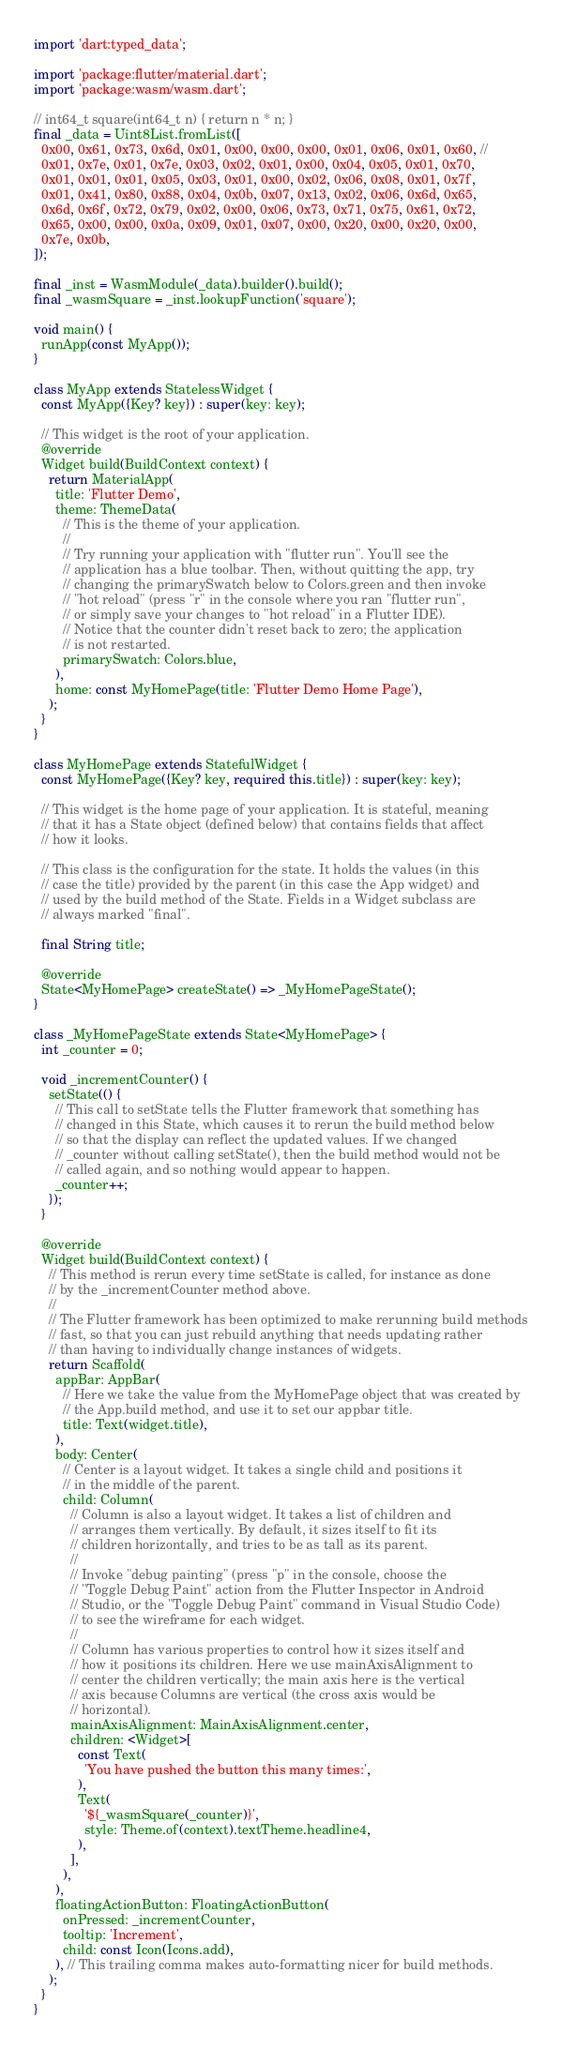<code> <loc_0><loc_0><loc_500><loc_500><_Dart_>import 'dart:typed_data';

import 'package:flutter/material.dart';
import 'package:wasm/wasm.dart';

// int64_t square(int64_t n) { return n * n; }
final _data = Uint8List.fromList([
  0x00, 0x61, 0x73, 0x6d, 0x01, 0x00, 0x00, 0x00, 0x01, 0x06, 0x01, 0x60, //
  0x01, 0x7e, 0x01, 0x7e, 0x03, 0x02, 0x01, 0x00, 0x04, 0x05, 0x01, 0x70,
  0x01, 0x01, 0x01, 0x05, 0x03, 0x01, 0x00, 0x02, 0x06, 0x08, 0x01, 0x7f,
  0x01, 0x41, 0x80, 0x88, 0x04, 0x0b, 0x07, 0x13, 0x02, 0x06, 0x6d, 0x65,
  0x6d, 0x6f, 0x72, 0x79, 0x02, 0x00, 0x06, 0x73, 0x71, 0x75, 0x61, 0x72,
  0x65, 0x00, 0x00, 0x0a, 0x09, 0x01, 0x07, 0x00, 0x20, 0x00, 0x20, 0x00,
  0x7e, 0x0b,
]);

final _inst = WasmModule(_data).builder().build();
final _wasmSquare = _inst.lookupFunction('square');

void main() {
  runApp(const MyApp());
}

class MyApp extends StatelessWidget {
  const MyApp({Key? key}) : super(key: key);

  // This widget is the root of your application.
  @override
  Widget build(BuildContext context) {
    return MaterialApp(
      title: 'Flutter Demo',
      theme: ThemeData(
        // This is the theme of your application.
        //
        // Try running your application with "flutter run". You'll see the
        // application has a blue toolbar. Then, without quitting the app, try
        // changing the primarySwatch below to Colors.green and then invoke
        // "hot reload" (press "r" in the console where you ran "flutter run",
        // or simply save your changes to "hot reload" in a Flutter IDE).
        // Notice that the counter didn't reset back to zero; the application
        // is not restarted.
        primarySwatch: Colors.blue,
      ),
      home: const MyHomePage(title: 'Flutter Demo Home Page'),
    );
  }
}

class MyHomePage extends StatefulWidget {
  const MyHomePage({Key? key, required this.title}) : super(key: key);

  // This widget is the home page of your application. It is stateful, meaning
  // that it has a State object (defined below) that contains fields that affect
  // how it looks.

  // This class is the configuration for the state. It holds the values (in this
  // case the title) provided by the parent (in this case the App widget) and
  // used by the build method of the State. Fields in a Widget subclass are
  // always marked "final".

  final String title;

  @override
  State<MyHomePage> createState() => _MyHomePageState();
}

class _MyHomePageState extends State<MyHomePage> {
  int _counter = 0;

  void _incrementCounter() {
    setState(() {
      // This call to setState tells the Flutter framework that something has
      // changed in this State, which causes it to rerun the build method below
      // so that the display can reflect the updated values. If we changed
      // _counter without calling setState(), then the build method would not be
      // called again, and so nothing would appear to happen.
      _counter++;
    });
  }

  @override
  Widget build(BuildContext context) {
    // This method is rerun every time setState is called, for instance as done
    // by the _incrementCounter method above.
    //
    // The Flutter framework has been optimized to make rerunning build methods
    // fast, so that you can just rebuild anything that needs updating rather
    // than having to individually change instances of widgets.
    return Scaffold(
      appBar: AppBar(
        // Here we take the value from the MyHomePage object that was created by
        // the App.build method, and use it to set our appbar title.
        title: Text(widget.title),
      ),
      body: Center(
        // Center is a layout widget. It takes a single child and positions it
        // in the middle of the parent.
        child: Column(
          // Column is also a layout widget. It takes a list of children and
          // arranges them vertically. By default, it sizes itself to fit its
          // children horizontally, and tries to be as tall as its parent.
          //
          // Invoke "debug painting" (press "p" in the console, choose the
          // "Toggle Debug Paint" action from the Flutter Inspector in Android
          // Studio, or the "Toggle Debug Paint" command in Visual Studio Code)
          // to see the wireframe for each widget.
          //
          // Column has various properties to control how it sizes itself and
          // how it positions its children. Here we use mainAxisAlignment to
          // center the children vertically; the main axis here is the vertical
          // axis because Columns are vertical (the cross axis would be
          // horizontal).
          mainAxisAlignment: MainAxisAlignment.center,
          children: <Widget>[
            const Text(
              'You have pushed the button this many times:',
            ),
            Text(
              '${_wasmSquare(_counter)}',
              style: Theme.of(context).textTheme.headline4,
            ),
          ],
        ),
      ),
      floatingActionButton: FloatingActionButton(
        onPressed: _incrementCounter,
        tooltip: 'Increment',
        child: const Icon(Icons.add),
      ), // This trailing comma makes auto-formatting nicer for build methods.
    );
  }
}
</code> 